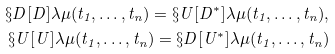Convert formula to latex. <formula><loc_0><loc_0><loc_500><loc_500>\S D [ D ] { \lambda } { \mu } ( t _ { 1 } , \dots , t _ { n } ) = \S U [ D ^ { \ast } ] { \lambda } { \mu } ( t _ { 1 } , \dots , t _ { n } ) , \\ \S U [ U ] { \lambda } { \mu } ( t _ { 1 } , \dots , t _ { n } ) = \S D [ U ^ { \ast } ] { \lambda } { \mu } ( t _ { 1 } , \dots , t _ { n } )</formula> 